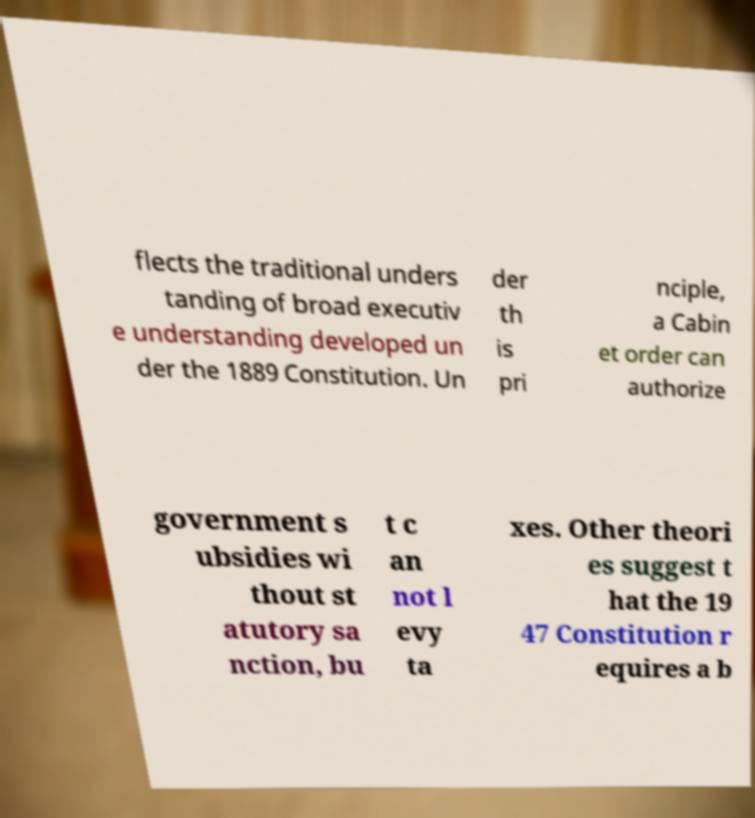What messages or text are displayed in this image? I need them in a readable, typed format. flects the traditional unders tanding of broad executiv e understanding developed un der the 1889 Constitution. Un der th is pri nciple, a Cabin et order can authorize government s ubsidies wi thout st atutory sa nction, bu t c an not l evy ta xes. Other theori es suggest t hat the 19 47 Constitution r equires a b 